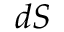<formula> <loc_0><loc_0><loc_500><loc_500>d S</formula> 